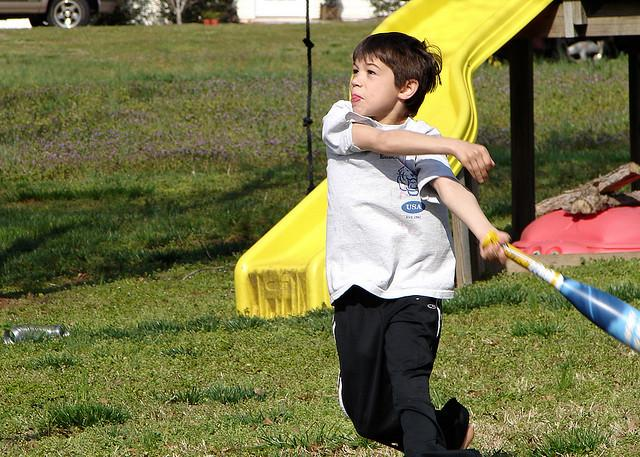What is the boy looking at? ball 